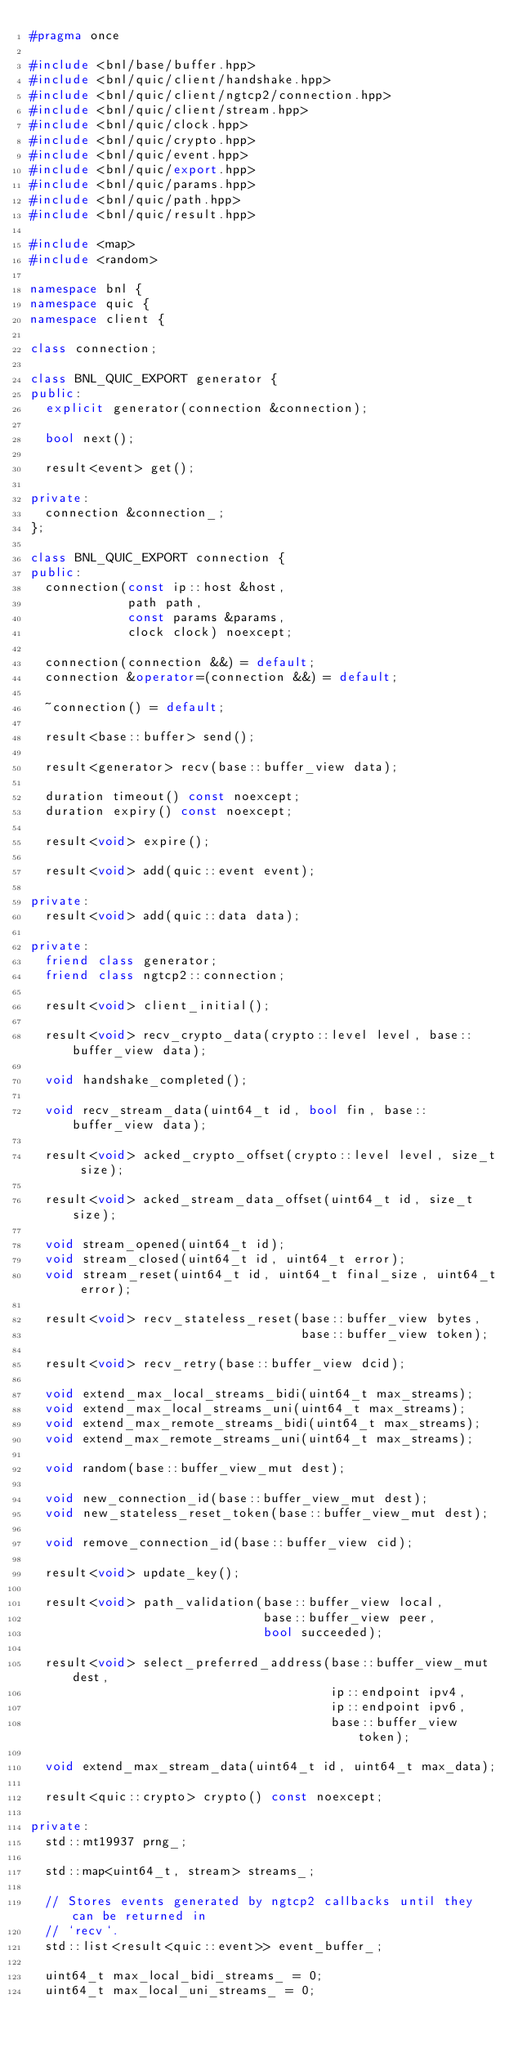Convert code to text. <code><loc_0><loc_0><loc_500><loc_500><_C++_>#pragma once

#include <bnl/base/buffer.hpp>
#include <bnl/quic/client/handshake.hpp>
#include <bnl/quic/client/ngtcp2/connection.hpp>
#include <bnl/quic/client/stream.hpp>
#include <bnl/quic/clock.hpp>
#include <bnl/quic/crypto.hpp>
#include <bnl/quic/event.hpp>
#include <bnl/quic/export.hpp>
#include <bnl/quic/params.hpp>
#include <bnl/quic/path.hpp>
#include <bnl/quic/result.hpp>

#include <map>
#include <random>

namespace bnl {
namespace quic {
namespace client {

class connection;

class BNL_QUIC_EXPORT generator {
public:
  explicit generator(connection &connection);

  bool next();

  result<event> get();

private:
  connection &connection_;
};

class BNL_QUIC_EXPORT connection {
public:
  connection(const ip::host &host,
             path path,
             const params &params,
             clock clock) noexcept;

  connection(connection &&) = default;
  connection &operator=(connection &&) = default;

  ~connection() = default;

  result<base::buffer> send();

  result<generator> recv(base::buffer_view data);

  duration timeout() const noexcept;
  duration expiry() const noexcept;

  result<void> expire();

  result<void> add(quic::event event);

private:
  result<void> add(quic::data data);

private:
  friend class generator;
  friend class ngtcp2::connection;

  result<void> client_initial();

  result<void> recv_crypto_data(crypto::level level, base::buffer_view data);

  void handshake_completed();

  void recv_stream_data(uint64_t id, bool fin, base::buffer_view data);

  result<void> acked_crypto_offset(crypto::level level, size_t size);

  result<void> acked_stream_data_offset(uint64_t id, size_t size);

  void stream_opened(uint64_t id);
  void stream_closed(uint64_t id, uint64_t error);
  void stream_reset(uint64_t id, uint64_t final_size, uint64_t error);

  result<void> recv_stateless_reset(base::buffer_view bytes,
                                    base::buffer_view token);

  result<void> recv_retry(base::buffer_view dcid);

  void extend_max_local_streams_bidi(uint64_t max_streams);
  void extend_max_local_streams_uni(uint64_t max_streams);
  void extend_max_remote_streams_bidi(uint64_t max_streams);
  void extend_max_remote_streams_uni(uint64_t max_streams);

  void random(base::buffer_view_mut dest);

  void new_connection_id(base::buffer_view_mut dest);
  void new_stateless_reset_token(base::buffer_view_mut dest);

  void remove_connection_id(base::buffer_view cid);

  result<void> update_key();

  result<void> path_validation(base::buffer_view local,
                               base::buffer_view peer,
                               bool succeeded);

  result<void> select_preferred_address(base::buffer_view_mut dest,
                                        ip::endpoint ipv4,
                                        ip::endpoint ipv6,
                                        base::buffer_view token);

  void extend_max_stream_data(uint64_t id, uint64_t max_data);

  result<quic::crypto> crypto() const noexcept;

private:
  std::mt19937 prng_;

  std::map<uint64_t, stream> streams_;

  // Stores events generated by ngtcp2 callbacks until they can be returned in
  // `recv`.
  std::list<result<quic::event>> event_buffer_;

  uint64_t max_local_bidi_streams_ = 0;
  uint64_t max_local_uni_streams_ = 0;</code> 